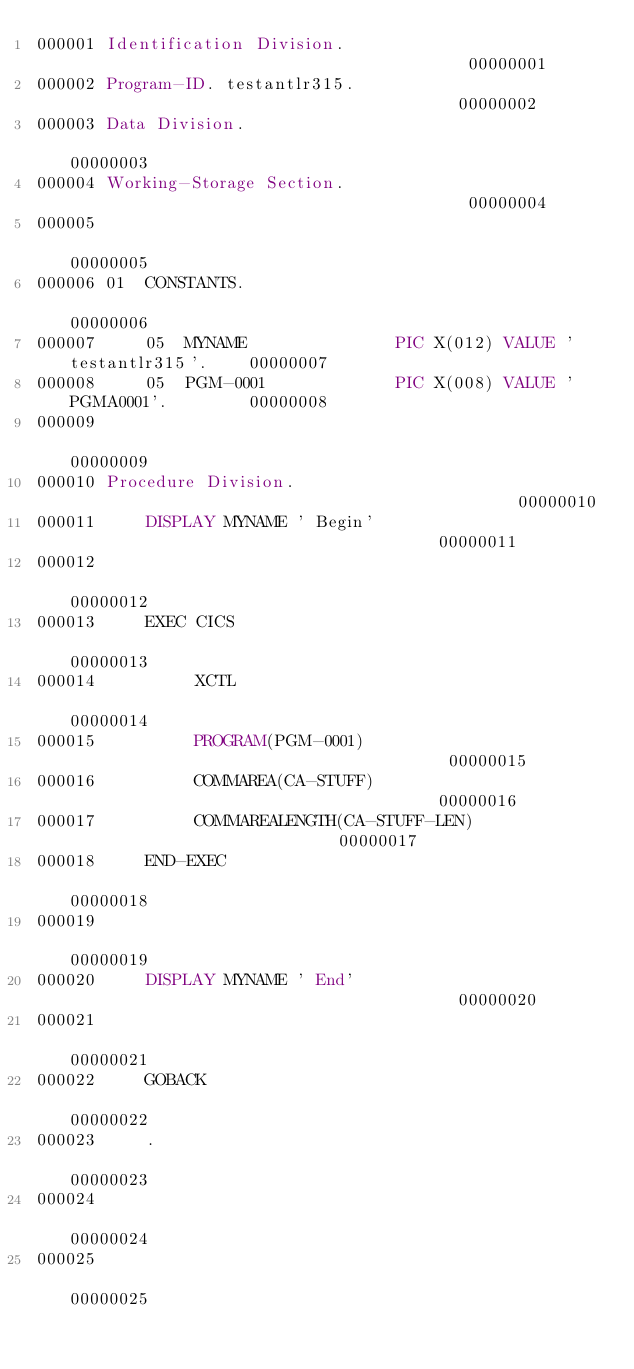Convert code to text. <code><loc_0><loc_0><loc_500><loc_500><_COBOL_>000001 Identification Division.                                         00000001
000002 Program-ID. testantlr315.                                        00000002
000003 Data Division.                                                   00000003
000004 Working-Storage Section.                                         00000004
000005                                                                  00000005
000006 01  CONSTANTS.                                                   00000006
000007     05  MYNAME               PIC X(012) VALUE 'testantlr315'.    00000007
000008     05  PGM-0001             PIC X(008) VALUE 'PGMA0001'.        00000008
000009                                                                  00000009
000010 Procedure Division.                                              00000010
000011     DISPLAY MYNAME ' Begin'                                      00000011
000012                                                                  00000012
000013     EXEC CICS                                                    00000013
000014          XCTL                                                    00000014
000015          PROGRAM(PGM-0001)                                       00000015
000016          COMMAREA(CA-STUFF)                                      00000016
000017          COMMAREALENGTH(CA-STUFF-LEN)                            00000017
000018     END-EXEC                                                     00000018
000019                                                                  00000019
000020     DISPLAY MYNAME ' End'                                        00000020
000021                                                                  00000021
000022     GOBACK                                                       00000022
000023     .                                                            00000023
000024                                                                  00000024
000025                                                                  00000025
</code> 